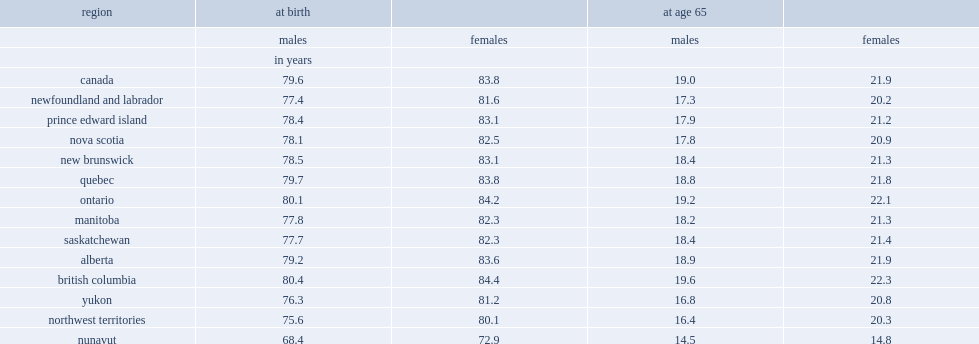What was the life expectancy for men and women at birth in british columbia respectively? 80.4 84.4. Which region had the lowest life expectancy at birth? Nunavut. 